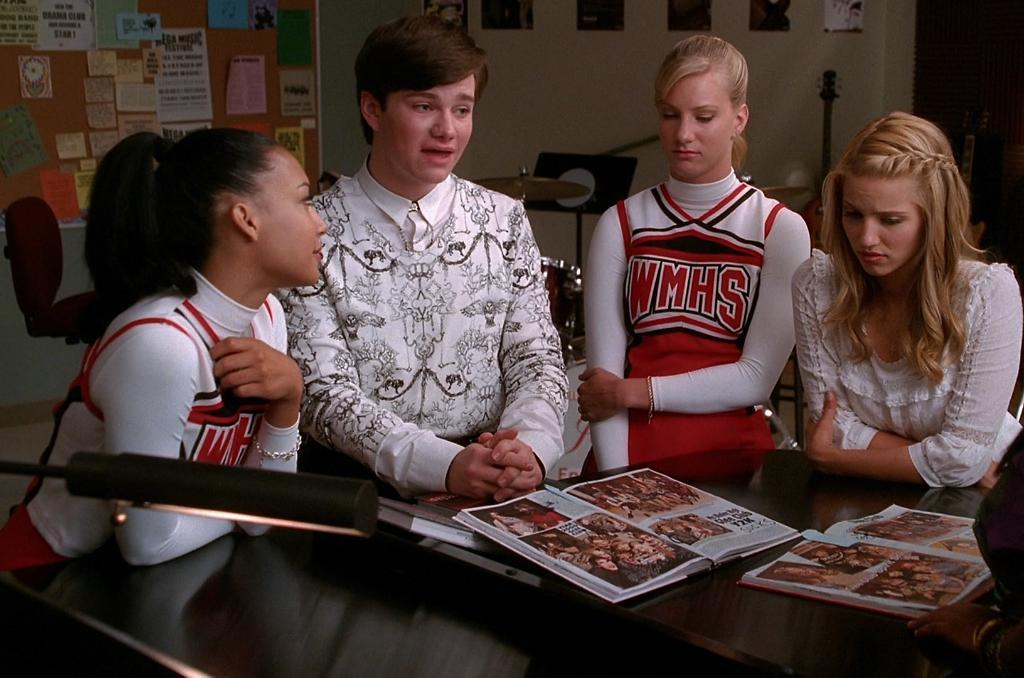Provide a one-sentence caption for the provided image. Two cheerleaders from WMHS sit with their friends. 